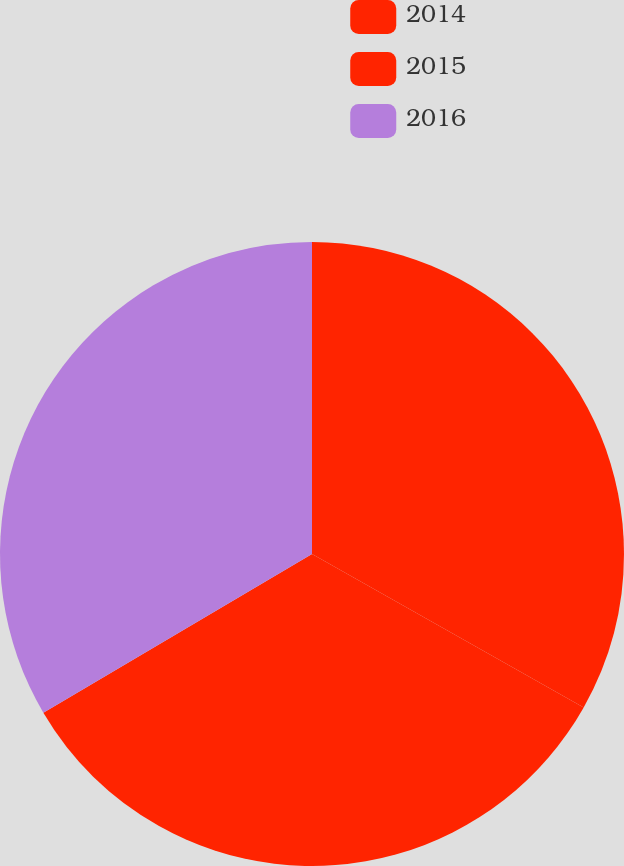Convert chart. <chart><loc_0><loc_0><loc_500><loc_500><pie_chart><fcel>2014<fcel>2015<fcel>2016<nl><fcel>33.18%<fcel>33.33%<fcel>33.49%<nl></chart> 